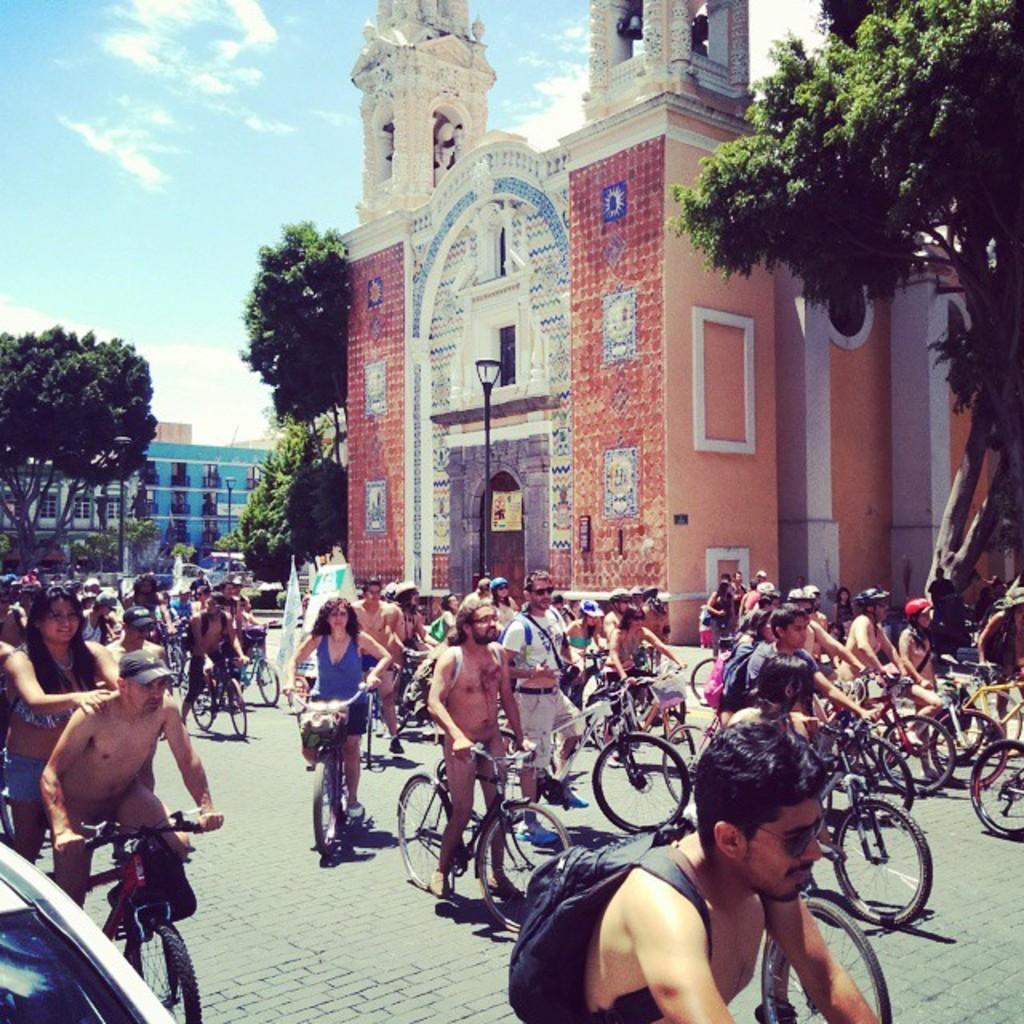How many people are in the image? There is a group of people in the image. What are the people doing in the image? The people are riding a bicycle. What objects can be seen in the image related to the bicycle? There is a bag and a basket in the image. What type of structure is visible in the image? There is a building in the image. What type of lighting is present in the image? There is a street light in the image. What type of vegetation is visible in the image? There are trees in the image. What type of transportation is visible in the image? There is a vehicle in the image. What is the condition of the sky in the image? The sky is blue and cloudy. How much payment is required to touch the vehicle in the image? There is no mention of payment or touching the vehicle in the image. The vehicle is simply a part of the scene. 